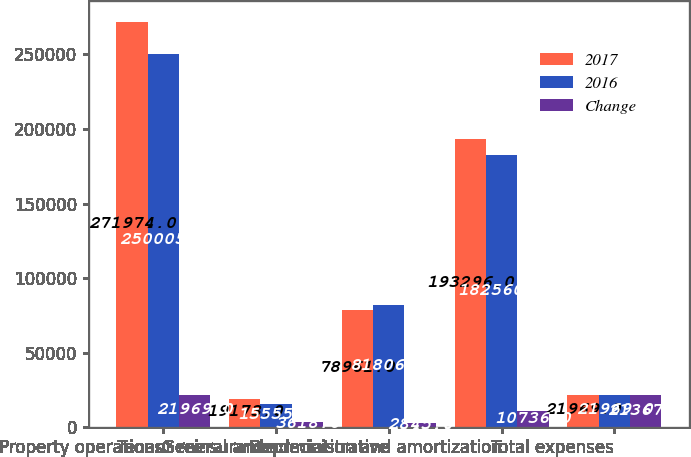<chart> <loc_0><loc_0><loc_500><loc_500><stacked_bar_chart><ecel><fcel>Property operations<fcel>Tenant reinsurance<fcel>General and administrative<fcel>Depreciation and amortization<fcel>Total expenses<nl><fcel>2017<fcel>271974<fcel>19173<fcel>78961<fcel>193296<fcel>21969<nl><fcel>2016<fcel>250005<fcel>15555<fcel>81806<fcel>182560<fcel>21969<nl><fcel>Change<fcel>21969<fcel>3618<fcel>2845<fcel>10736<fcel>21367<nl></chart> 